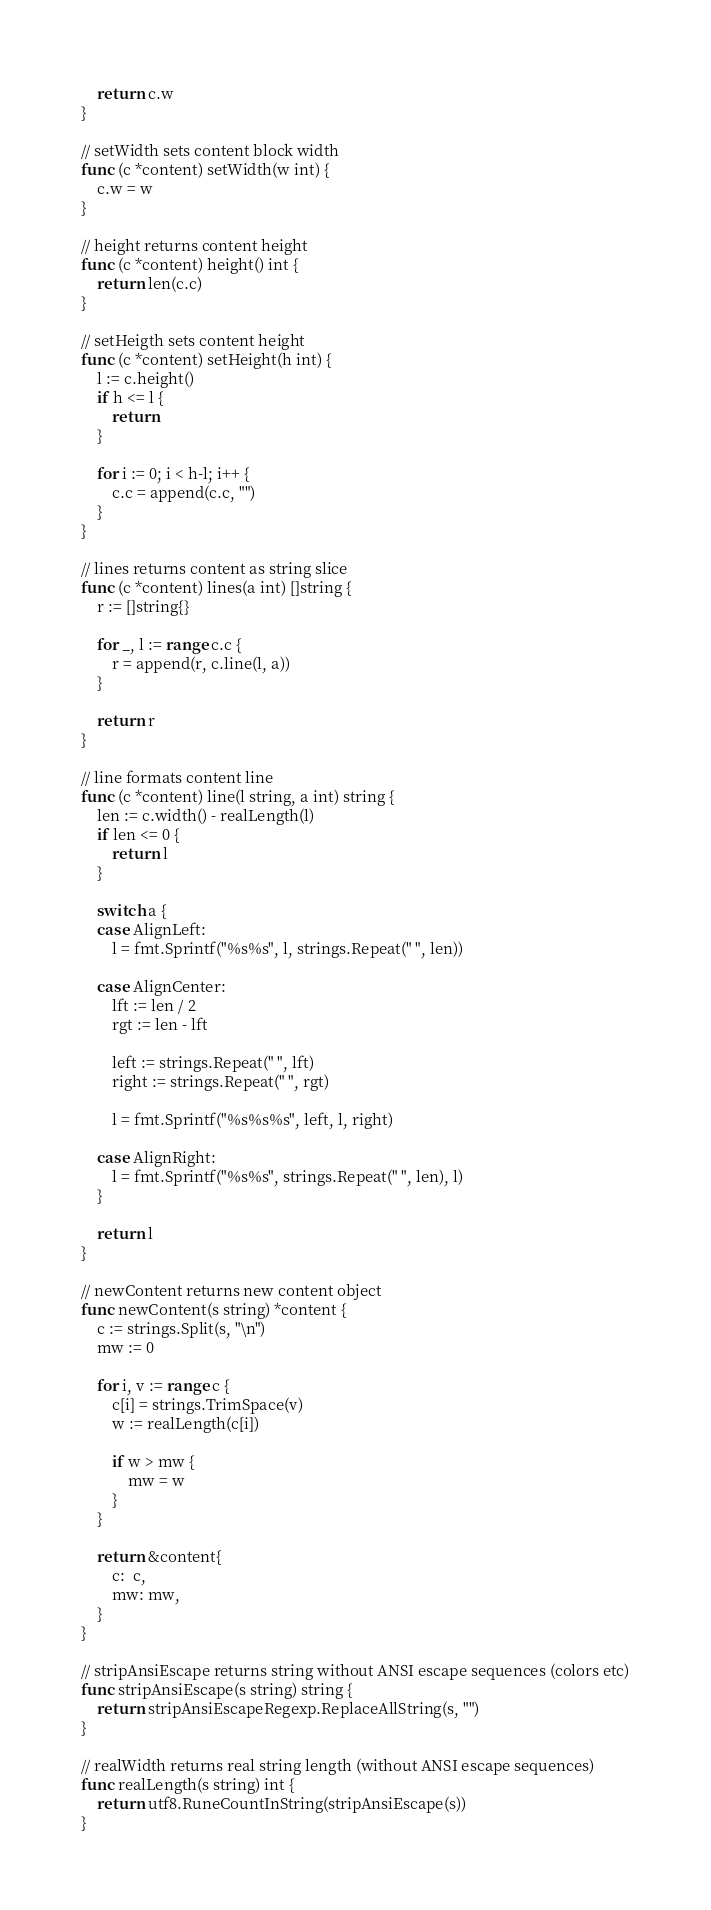Convert code to text. <code><loc_0><loc_0><loc_500><loc_500><_Go_>	return c.w
}

// setWidth sets content block width
func (c *content) setWidth(w int) {
	c.w = w
}

// height returns content height
func (c *content) height() int {
	return len(c.c)
}

// setHeigth sets content height
func (c *content) setHeight(h int) {
	l := c.height()
	if h <= l {
		return
	}

	for i := 0; i < h-l; i++ {
		c.c = append(c.c, "")
	}
}

// lines returns content as string slice
func (c *content) lines(a int) []string {
	r := []string{}

	for _, l := range c.c {
		r = append(r, c.line(l, a))
	}

	return r
}

// line formats content line
func (c *content) line(l string, a int) string {
	len := c.width() - realLength(l)
	if len <= 0 {
		return l
	}

	switch a {
	case AlignLeft:
		l = fmt.Sprintf("%s%s", l, strings.Repeat(" ", len))

	case AlignCenter:
		lft := len / 2
		rgt := len - lft

		left := strings.Repeat(" ", lft)
		right := strings.Repeat(" ", rgt)

		l = fmt.Sprintf("%s%s%s", left, l, right)

	case AlignRight:
		l = fmt.Sprintf("%s%s", strings.Repeat(" ", len), l)
	}

	return l
}

// newContent returns new content object
func newContent(s string) *content {
	c := strings.Split(s, "\n")
	mw := 0

	for i, v := range c {
		c[i] = strings.TrimSpace(v)
		w := realLength(c[i])

		if w > mw {
			mw = w
		}
	}

	return &content{
		c:  c,
		mw: mw,
	}
}

// stripAnsiEscape returns string without ANSI escape sequences (colors etc)
func stripAnsiEscape(s string) string {
	return stripAnsiEscapeRegexp.ReplaceAllString(s, "")
}

// realWidth returns real string length (without ANSI escape sequences)
func realLength(s string) int {
	return utf8.RuneCountInString(stripAnsiEscape(s))
}
</code> 